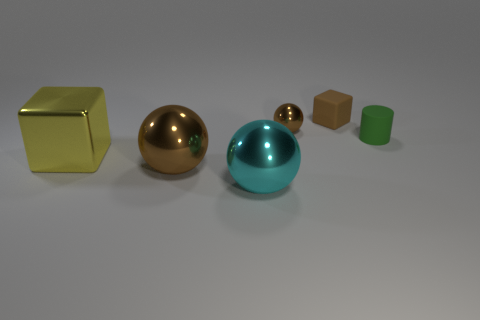There is a cyan thing that is made of the same material as the big cube; what size is it?
Keep it short and to the point. Large. Is there anything else that is the same color as the matte cylinder?
Offer a very short reply. No. There is a object that is right of the brown matte cube; is its color the same as the tiny object that is to the left of the brown rubber cube?
Ensure brevity in your answer.  No. There is a small object that is behind the tiny sphere; what color is it?
Your response must be concise. Brown. There is a ball that is behind the yellow cube; does it have the same size as the yellow object?
Make the answer very short. No. Is the number of tiny rubber blocks less than the number of balls?
Offer a very short reply. Yes. What shape is the big object that is the same color as the tiny cube?
Offer a very short reply. Sphere. There is a big yellow metal thing; what number of large objects are left of it?
Keep it short and to the point. 0. Do the cyan thing and the yellow thing have the same shape?
Provide a succinct answer. No. What number of things are both to the left of the small brown rubber block and behind the large cyan sphere?
Your answer should be compact. 3. 